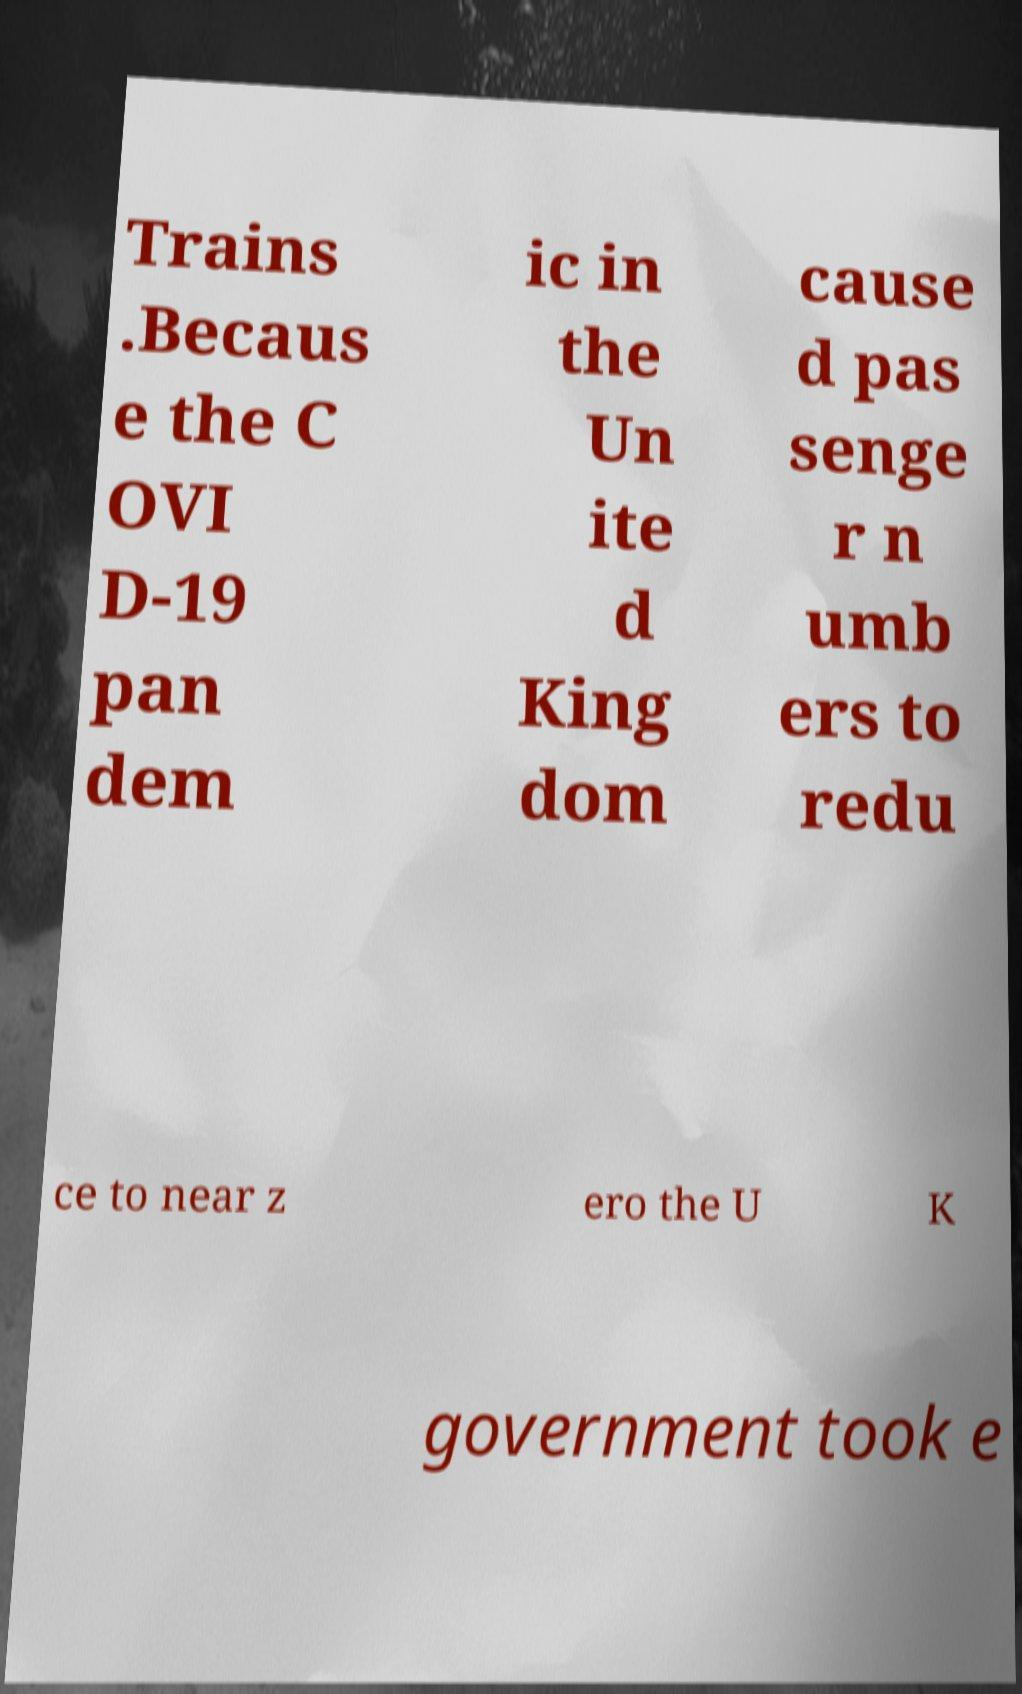Could you assist in decoding the text presented in this image and type it out clearly? Trains .Becaus e the C OVI D-19 pan dem ic in the Un ite d King dom cause d pas senge r n umb ers to redu ce to near z ero the U K government took e 